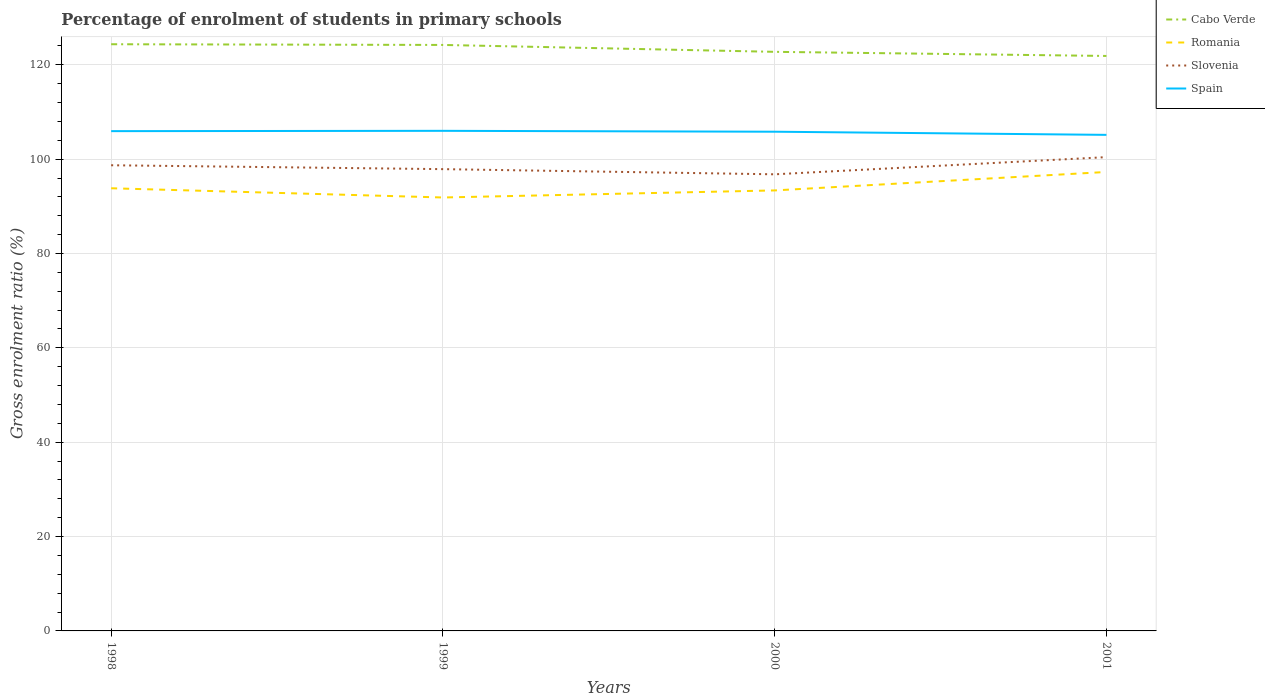Is the number of lines equal to the number of legend labels?
Offer a very short reply. Yes. Across all years, what is the maximum percentage of students enrolled in primary schools in Spain?
Offer a very short reply. 105.15. In which year was the percentage of students enrolled in primary schools in Romania maximum?
Provide a succinct answer. 1999. What is the total percentage of students enrolled in primary schools in Slovenia in the graph?
Offer a very short reply. -1.72. What is the difference between the highest and the second highest percentage of students enrolled in primary schools in Romania?
Your response must be concise. 5.41. Is the percentage of students enrolled in primary schools in Slovenia strictly greater than the percentage of students enrolled in primary schools in Cabo Verde over the years?
Make the answer very short. Yes. How many lines are there?
Your answer should be very brief. 4. How many years are there in the graph?
Your response must be concise. 4. What is the difference between two consecutive major ticks on the Y-axis?
Offer a terse response. 20. Does the graph contain grids?
Your response must be concise. Yes. Where does the legend appear in the graph?
Give a very brief answer. Top right. How many legend labels are there?
Your response must be concise. 4. How are the legend labels stacked?
Provide a short and direct response. Vertical. What is the title of the graph?
Your answer should be very brief. Percentage of enrolment of students in primary schools. Does "Paraguay" appear as one of the legend labels in the graph?
Offer a very short reply. No. What is the label or title of the X-axis?
Offer a terse response. Years. What is the label or title of the Y-axis?
Your answer should be compact. Gross enrolment ratio (%). What is the Gross enrolment ratio (%) in Cabo Verde in 1998?
Your answer should be very brief. 124.36. What is the Gross enrolment ratio (%) in Romania in 1998?
Your answer should be compact. 93.83. What is the Gross enrolment ratio (%) in Slovenia in 1998?
Make the answer very short. 98.71. What is the Gross enrolment ratio (%) in Spain in 1998?
Offer a very short reply. 105.94. What is the Gross enrolment ratio (%) in Cabo Verde in 1999?
Provide a short and direct response. 124.21. What is the Gross enrolment ratio (%) of Romania in 1999?
Your response must be concise. 91.88. What is the Gross enrolment ratio (%) in Slovenia in 1999?
Ensure brevity in your answer.  97.88. What is the Gross enrolment ratio (%) of Spain in 1999?
Your answer should be very brief. 106.01. What is the Gross enrolment ratio (%) of Cabo Verde in 2000?
Your response must be concise. 122.75. What is the Gross enrolment ratio (%) in Romania in 2000?
Give a very brief answer. 93.37. What is the Gross enrolment ratio (%) in Slovenia in 2000?
Offer a very short reply. 96.79. What is the Gross enrolment ratio (%) of Spain in 2000?
Ensure brevity in your answer.  105.82. What is the Gross enrolment ratio (%) of Cabo Verde in 2001?
Your response must be concise. 121.88. What is the Gross enrolment ratio (%) in Romania in 2001?
Your answer should be compact. 97.29. What is the Gross enrolment ratio (%) of Slovenia in 2001?
Your answer should be compact. 100.43. What is the Gross enrolment ratio (%) in Spain in 2001?
Provide a succinct answer. 105.15. Across all years, what is the maximum Gross enrolment ratio (%) in Cabo Verde?
Provide a short and direct response. 124.36. Across all years, what is the maximum Gross enrolment ratio (%) in Romania?
Keep it short and to the point. 97.29. Across all years, what is the maximum Gross enrolment ratio (%) of Slovenia?
Make the answer very short. 100.43. Across all years, what is the maximum Gross enrolment ratio (%) in Spain?
Your response must be concise. 106.01. Across all years, what is the minimum Gross enrolment ratio (%) of Cabo Verde?
Offer a very short reply. 121.88. Across all years, what is the minimum Gross enrolment ratio (%) in Romania?
Provide a succinct answer. 91.88. Across all years, what is the minimum Gross enrolment ratio (%) of Slovenia?
Offer a very short reply. 96.79. Across all years, what is the minimum Gross enrolment ratio (%) of Spain?
Provide a short and direct response. 105.15. What is the total Gross enrolment ratio (%) in Cabo Verde in the graph?
Keep it short and to the point. 493.2. What is the total Gross enrolment ratio (%) of Romania in the graph?
Ensure brevity in your answer.  376.37. What is the total Gross enrolment ratio (%) in Slovenia in the graph?
Offer a very short reply. 393.81. What is the total Gross enrolment ratio (%) of Spain in the graph?
Offer a terse response. 422.92. What is the difference between the Gross enrolment ratio (%) of Cabo Verde in 1998 and that in 1999?
Keep it short and to the point. 0.15. What is the difference between the Gross enrolment ratio (%) in Romania in 1998 and that in 1999?
Ensure brevity in your answer.  1.96. What is the difference between the Gross enrolment ratio (%) of Slovenia in 1998 and that in 1999?
Offer a very short reply. 0.82. What is the difference between the Gross enrolment ratio (%) of Spain in 1998 and that in 1999?
Your response must be concise. -0.07. What is the difference between the Gross enrolment ratio (%) in Cabo Verde in 1998 and that in 2000?
Provide a short and direct response. 1.61. What is the difference between the Gross enrolment ratio (%) in Romania in 1998 and that in 2000?
Ensure brevity in your answer.  0.46. What is the difference between the Gross enrolment ratio (%) of Slovenia in 1998 and that in 2000?
Your answer should be very brief. 1.92. What is the difference between the Gross enrolment ratio (%) of Spain in 1998 and that in 2000?
Keep it short and to the point. 0.12. What is the difference between the Gross enrolment ratio (%) of Cabo Verde in 1998 and that in 2001?
Your response must be concise. 2.48. What is the difference between the Gross enrolment ratio (%) of Romania in 1998 and that in 2001?
Provide a short and direct response. -3.45. What is the difference between the Gross enrolment ratio (%) of Slovenia in 1998 and that in 2001?
Give a very brief answer. -1.72. What is the difference between the Gross enrolment ratio (%) of Spain in 1998 and that in 2001?
Offer a terse response. 0.79. What is the difference between the Gross enrolment ratio (%) of Cabo Verde in 1999 and that in 2000?
Your answer should be very brief. 1.46. What is the difference between the Gross enrolment ratio (%) of Romania in 1999 and that in 2000?
Your answer should be very brief. -1.5. What is the difference between the Gross enrolment ratio (%) in Slovenia in 1999 and that in 2000?
Give a very brief answer. 1.09. What is the difference between the Gross enrolment ratio (%) of Spain in 1999 and that in 2000?
Your answer should be very brief. 0.19. What is the difference between the Gross enrolment ratio (%) in Cabo Verde in 1999 and that in 2001?
Keep it short and to the point. 2.33. What is the difference between the Gross enrolment ratio (%) of Romania in 1999 and that in 2001?
Provide a succinct answer. -5.41. What is the difference between the Gross enrolment ratio (%) of Slovenia in 1999 and that in 2001?
Make the answer very short. -2.55. What is the difference between the Gross enrolment ratio (%) of Spain in 1999 and that in 2001?
Provide a short and direct response. 0.86. What is the difference between the Gross enrolment ratio (%) in Cabo Verde in 2000 and that in 2001?
Your answer should be compact. 0.87. What is the difference between the Gross enrolment ratio (%) in Romania in 2000 and that in 2001?
Give a very brief answer. -3.91. What is the difference between the Gross enrolment ratio (%) of Slovenia in 2000 and that in 2001?
Offer a very short reply. -3.64. What is the difference between the Gross enrolment ratio (%) in Spain in 2000 and that in 2001?
Ensure brevity in your answer.  0.67. What is the difference between the Gross enrolment ratio (%) of Cabo Verde in 1998 and the Gross enrolment ratio (%) of Romania in 1999?
Your answer should be compact. 32.48. What is the difference between the Gross enrolment ratio (%) of Cabo Verde in 1998 and the Gross enrolment ratio (%) of Slovenia in 1999?
Provide a short and direct response. 26.48. What is the difference between the Gross enrolment ratio (%) in Cabo Verde in 1998 and the Gross enrolment ratio (%) in Spain in 1999?
Make the answer very short. 18.35. What is the difference between the Gross enrolment ratio (%) in Romania in 1998 and the Gross enrolment ratio (%) in Slovenia in 1999?
Provide a short and direct response. -4.05. What is the difference between the Gross enrolment ratio (%) of Romania in 1998 and the Gross enrolment ratio (%) of Spain in 1999?
Offer a very short reply. -12.18. What is the difference between the Gross enrolment ratio (%) in Slovenia in 1998 and the Gross enrolment ratio (%) in Spain in 1999?
Your response must be concise. -7.3. What is the difference between the Gross enrolment ratio (%) of Cabo Verde in 1998 and the Gross enrolment ratio (%) of Romania in 2000?
Provide a succinct answer. 30.99. What is the difference between the Gross enrolment ratio (%) of Cabo Verde in 1998 and the Gross enrolment ratio (%) of Slovenia in 2000?
Provide a short and direct response. 27.57. What is the difference between the Gross enrolment ratio (%) in Cabo Verde in 1998 and the Gross enrolment ratio (%) in Spain in 2000?
Your response must be concise. 18.54. What is the difference between the Gross enrolment ratio (%) of Romania in 1998 and the Gross enrolment ratio (%) of Slovenia in 2000?
Make the answer very short. -2.96. What is the difference between the Gross enrolment ratio (%) in Romania in 1998 and the Gross enrolment ratio (%) in Spain in 2000?
Your response must be concise. -11.99. What is the difference between the Gross enrolment ratio (%) in Slovenia in 1998 and the Gross enrolment ratio (%) in Spain in 2000?
Offer a very short reply. -7.11. What is the difference between the Gross enrolment ratio (%) of Cabo Verde in 1998 and the Gross enrolment ratio (%) of Romania in 2001?
Your response must be concise. 27.08. What is the difference between the Gross enrolment ratio (%) in Cabo Verde in 1998 and the Gross enrolment ratio (%) in Slovenia in 2001?
Provide a short and direct response. 23.93. What is the difference between the Gross enrolment ratio (%) of Cabo Verde in 1998 and the Gross enrolment ratio (%) of Spain in 2001?
Ensure brevity in your answer.  19.21. What is the difference between the Gross enrolment ratio (%) of Romania in 1998 and the Gross enrolment ratio (%) of Slovenia in 2001?
Give a very brief answer. -6.6. What is the difference between the Gross enrolment ratio (%) in Romania in 1998 and the Gross enrolment ratio (%) in Spain in 2001?
Offer a terse response. -11.32. What is the difference between the Gross enrolment ratio (%) in Slovenia in 1998 and the Gross enrolment ratio (%) in Spain in 2001?
Your answer should be very brief. -6.44. What is the difference between the Gross enrolment ratio (%) in Cabo Verde in 1999 and the Gross enrolment ratio (%) in Romania in 2000?
Keep it short and to the point. 30.84. What is the difference between the Gross enrolment ratio (%) in Cabo Verde in 1999 and the Gross enrolment ratio (%) in Slovenia in 2000?
Make the answer very short. 27.42. What is the difference between the Gross enrolment ratio (%) of Cabo Verde in 1999 and the Gross enrolment ratio (%) of Spain in 2000?
Keep it short and to the point. 18.39. What is the difference between the Gross enrolment ratio (%) in Romania in 1999 and the Gross enrolment ratio (%) in Slovenia in 2000?
Your answer should be very brief. -4.91. What is the difference between the Gross enrolment ratio (%) in Romania in 1999 and the Gross enrolment ratio (%) in Spain in 2000?
Give a very brief answer. -13.94. What is the difference between the Gross enrolment ratio (%) of Slovenia in 1999 and the Gross enrolment ratio (%) of Spain in 2000?
Your answer should be compact. -7.93. What is the difference between the Gross enrolment ratio (%) in Cabo Verde in 1999 and the Gross enrolment ratio (%) in Romania in 2001?
Give a very brief answer. 26.93. What is the difference between the Gross enrolment ratio (%) of Cabo Verde in 1999 and the Gross enrolment ratio (%) of Slovenia in 2001?
Your response must be concise. 23.78. What is the difference between the Gross enrolment ratio (%) of Cabo Verde in 1999 and the Gross enrolment ratio (%) of Spain in 2001?
Ensure brevity in your answer.  19.06. What is the difference between the Gross enrolment ratio (%) of Romania in 1999 and the Gross enrolment ratio (%) of Slovenia in 2001?
Give a very brief answer. -8.55. What is the difference between the Gross enrolment ratio (%) of Romania in 1999 and the Gross enrolment ratio (%) of Spain in 2001?
Keep it short and to the point. -13.28. What is the difference between the Gross enrolment ratio (%) of Slovenia in 1999 and the Gross enrolment ratio (%) of Spain in 2001?
Your answer should be very brief. -7.27. What is the difference between the Gross enrolment ratio (%) in Cabo Verde in 2000 and the Gross enrolment ratio (%) in Romania in 2001?
Offer a terse response. 25.47. What is the difference between the Gross enrolment ratio (%) of Cabo Verde in 2000 and the Gross enrolment ratio (%) of Slovenia in 2001?
Your answer should be compact. 22.32. What is the difference between the Gross enrolment ratio (%) in Cabo Verde in 2000 and the Gross enrolment ratio (%) in Spain in 2001?
Offer a very short reply. 17.6. What is the difference between the Gross enrolment ratio (%) in Romania in 2000 and the Gross enrolment ratio (%) in Slovenia in 2001?
Make the answer very short. -7.06. What is the difference between the Gross enrolment ratio (%) of Romania in 2000 and the Gross enrolment ratio (%) of Spain in 2001?
Provide a succinct answer. -11.78. What is the difference between the Gross enrolment ratio (%) in Slovenia in 2000 and the Gross enrolment ratio (%) in Spain in 2001?
Provide a short and direct response. -8.36. What is the average Gross enrolment ratio (%) of Cabo Verde per year?
Offer a terse response. 123.3. What is the average Gross enrolment ratio (%) in Romania per year?
Give a very brief answer. 94.09. What is the average Gross enrolment ratio (%) of Slovenia per year?
Keep it short and to the point. 98.45. What is the average Gross enrolment ratio (%) in Spain per year?
Your answer should be compact. 105.73. In the year 1998, what is the difference between the Gross enrolment ratio (%) of Cabo Verde and Gross enrolment ratio (%) of Romania?
Provide a short and direct response. 30.53. In the year 1998, what is the difference between the Gross enrolment ratio (%) in Cabo Verde and Gross enrolment ratio (%) in Slovenia?
Provide a succinct answer. 25.65. In the year 1998, what is the difference between the Gross enrolment ratio (%) of Cabo Verde and Gross enrolment ratio (%) of Spain?
Ensure brevity in your answer.  18.42. In the year 1998, what is the difference between the Gross enrolment ratio (%) of Romania and Gross enrolment ratio (%) of Slovenia?
Ensure brevity in your answer.  -4.88. In the year 1998, what is the difference between the Gross enrolment ratio (%) in Romania and Gross enrolment ratio (%) in Spain?
Your answer should be very brief. -12.11. In the year 1998, what is the difference between the Gross enrolment ratio (%) of Slovenia and Gross enrolment ratio (%) of Spain?
Give a very brief answer. -7.23. In the year 1999, what is the difference between the Gross enrolment ratio (%) of Cabo Verde and Gross enrolment ratio (%) of Romania?
Provide a succinct answer. 32.34. In the year 1999, what is the difference between the Gross enrolment ratio (%) in Cabo Verde and Gross enrolment ratio (%) in Slovenia?
Provide a succinct answer. 26.33. In the year 1999, what is the difference between the Gross enrolment ratio (%) in Cabo Verde and Gross enrolment ratio (%) in Spain?
Offer a very short reply. 18.2. In the year 1999, what is the difference between the Gross enrolment ratio (%) in Romania and Gross enrolment ratio (%) in Slovenia?
Keep it short and to the point. -6.01. In the year 1999, what is the difference between the Gross enrolment ratio (%) of Romania and Gross enrolment ratio (%) of Spain?
Ensure brevity in your answer.  -14.13. In the year 1999, what is the difference between the Gross enrolment ratio (%) of Slovenia and Gross enrolment ratio (%) of Spain?
Offer a terse response. -8.12. In the year 2000, what is the difference between the Gross enrolment ratio (%) in Cabo Verde and Gross enrolment ratio (%) in Romania?
Make the answer very short. 29.38. In the year 2000, what is the difference between the Gross enrolment ratio (%) of Cabo Verde and Gross enrolment ratio (%) of Slovenia?
Keep it short and to the point. 25.96. In the year 2000, what is the difference between the Gross enrolment ratio (%) in Cabo Verde and Gross enrolment ratio (%) in Spain?
Make the answer very short. 16.93. In the year 2000, what is the difference between the Gross enrolment ratio (%) of Romania and Gross enrolment ratio (%) of Slovenia?
Provide a succinct answer. -3.42. In the year 2000, what is the difference between the Gross enrolment ratio (%) in Romania and Gross enrolment ratio (%) in Spain?
Offer a very short reply. -12.44. In the year 2000, what is the difference between the Gross enrolment ratio (%) of Slovenia and Gross enrolment ratio (%) of Spain?
Provide a succinct answer. -9.03. In the year 2001, what is the difference between the Gross enrolment ratio (%) of Cabo Verde and Gross enrolment ratio (%) of Romania?
Provide a short and direct response. 24.59. In the year 2001, what is the difference between the Gross enrolment ratio (%) of Cabo Verde and Gross enrolment ratio (%) of Slovenia?
Your answer should be compact. 21.45. In the year 2001, what is the difference between the Gross enrolment ratio (%) in Cabo Verde and Gross enrolment ratio (%) in Spain?
Provide a short and direct response. 16.73. In the year 2001, what is the difference between the Gross enrolment ratio (%) in Romania and Gross enrolment ratio (%) in Slovenia?
Your response must be concise. -3.14. In the year 2001, what is the difference between the Gross enrolment ratio (%) in Romania and Gross enrolment ratio (%) in Spain?
Your answer should be compact. -7.87. In the year 2001, what is the difference between the Gross enrolment ratio (%) in Slovenia and Gross enrolment ratio (%) in Spain?
Offer a terse response. -4.72. What is the ratio of the Gross enrolment ratio (%) in Cabo Verde in 1998 to that in 1999?
Keep it short and to the point. 1. What is the ratio of the Gross enrolment ratio (%) in Romania in 1998 to that in 1999?
Offer a terse response. 1.02. What is the ratio of the Gross enrolment ratio (%) of Slovenia in 1998 to that in 1999?
Your answer should be compact. 1.01. What is the ratio of the Gross enrolment ratio (%) in Cabo Verde in 1998 to that in 2000?
Offer a very short reply. 1.01. What is the ratio of the Gross enrolment ratio (%) of Romania in 1998 to that in 2000?
Offer a very short reply. 1. What is the ratio of the Gross enrolment ratio (%) of Slovenia in 1998 to that in 2000?
Offer a terse response. 1.02. What is the ratio of the Gross enrolment ratio (%) of Cabo Verde in 1998 to that in 2001?
Give a very brief answer. 1.02. What is the ratio of the Gross enrolment ratio (%) of Romania in 1998 to that in 2001?
Ensure brevity in your answer.  0.96. What is the ratio of the Gross enrolment ratio (%) in Slovenia in 1998 to that in 2001?
Give a very brief answer. 0.98. What is the ratio of the Gross enrolment ratio (%) in Spain in 1998 to that in 2001?
Provide a short and direct response. 1.01. What is the ratio of the Gross enrolment ratio (%) of Cabo Verde in 1999 to that in 2000?
Your response must be concise. 1.01. What is the ratio of the Gross enrolment ratio (%) in Romania in 1999 to that in 2000?
Provide a short and direct response. 0.98. What is the ratio of the Gross enrolment ratio (%) of Slovenia in 1999 to that in 2000?
Provide a short and direct response. 1.01. What is the ratio of the Gross enrolment ratio (%) in Cabo Verde in 1999 to that in 2001?
Make the answer very short. 1.02. What is the ratio of the Gross enrolment ratio (%) of Romania in 1999 to that in 2001?
Provide a short and direct response. 0.94. What is the ratio of the Gross enrolment ratio (%) of Slovenia in 1999 to that in 2001?
Your answer should be compact. 0.97. What is the ratio of the Gross enrolment ratio (%) of Cabo Verde in 2000 to that in 2001?
Provide a short and direct response. 1.01. What is the ratio of the Gross enrolment ratio (%) of Romania in 2000 to that in 2001?
Keep it short and to the point. 0.96. What is the ratio of the Gross enrolment ratio (%) in Slovenia in 2000 to that in 2001?
Make the answer very short. 0.96. What is the difference between the highest and the second highest Gross enrolment ratio (%) of Cabo Verde?
Make the answer very short. 0.15. What is the difference between the highest and the second highest Gross enrolment ratio (%) in Romania?
Offer a very short reply. 3.45. What is the difference between the highest and the second highest Gross enrolment ratio (%) of Slovenia?
Give a very brief answer. 1.72. What is the difference between the highest and the second highest Gross enrolment ratio (%) in Spain?
Ensure brevity in your answer.  0.07. What is the difference between the highest and the lowest Gross enrolment ratio (%) of Cabo Verde?
Give a very brief answer. 2.48. What is the difference between the highest and the lowest Gross enrolment ratio (%) of Romania?
Offer a terse response. 5.41. What is the difference between the highest and the lowest Gross enrolment ratio (%) of Slovenia?
Provide a succinct answer. 3.64. What is the difference between the highest and the lowest Gross enrolment ratio (%) of Spain?
Give a very brief answer. 0.86. 